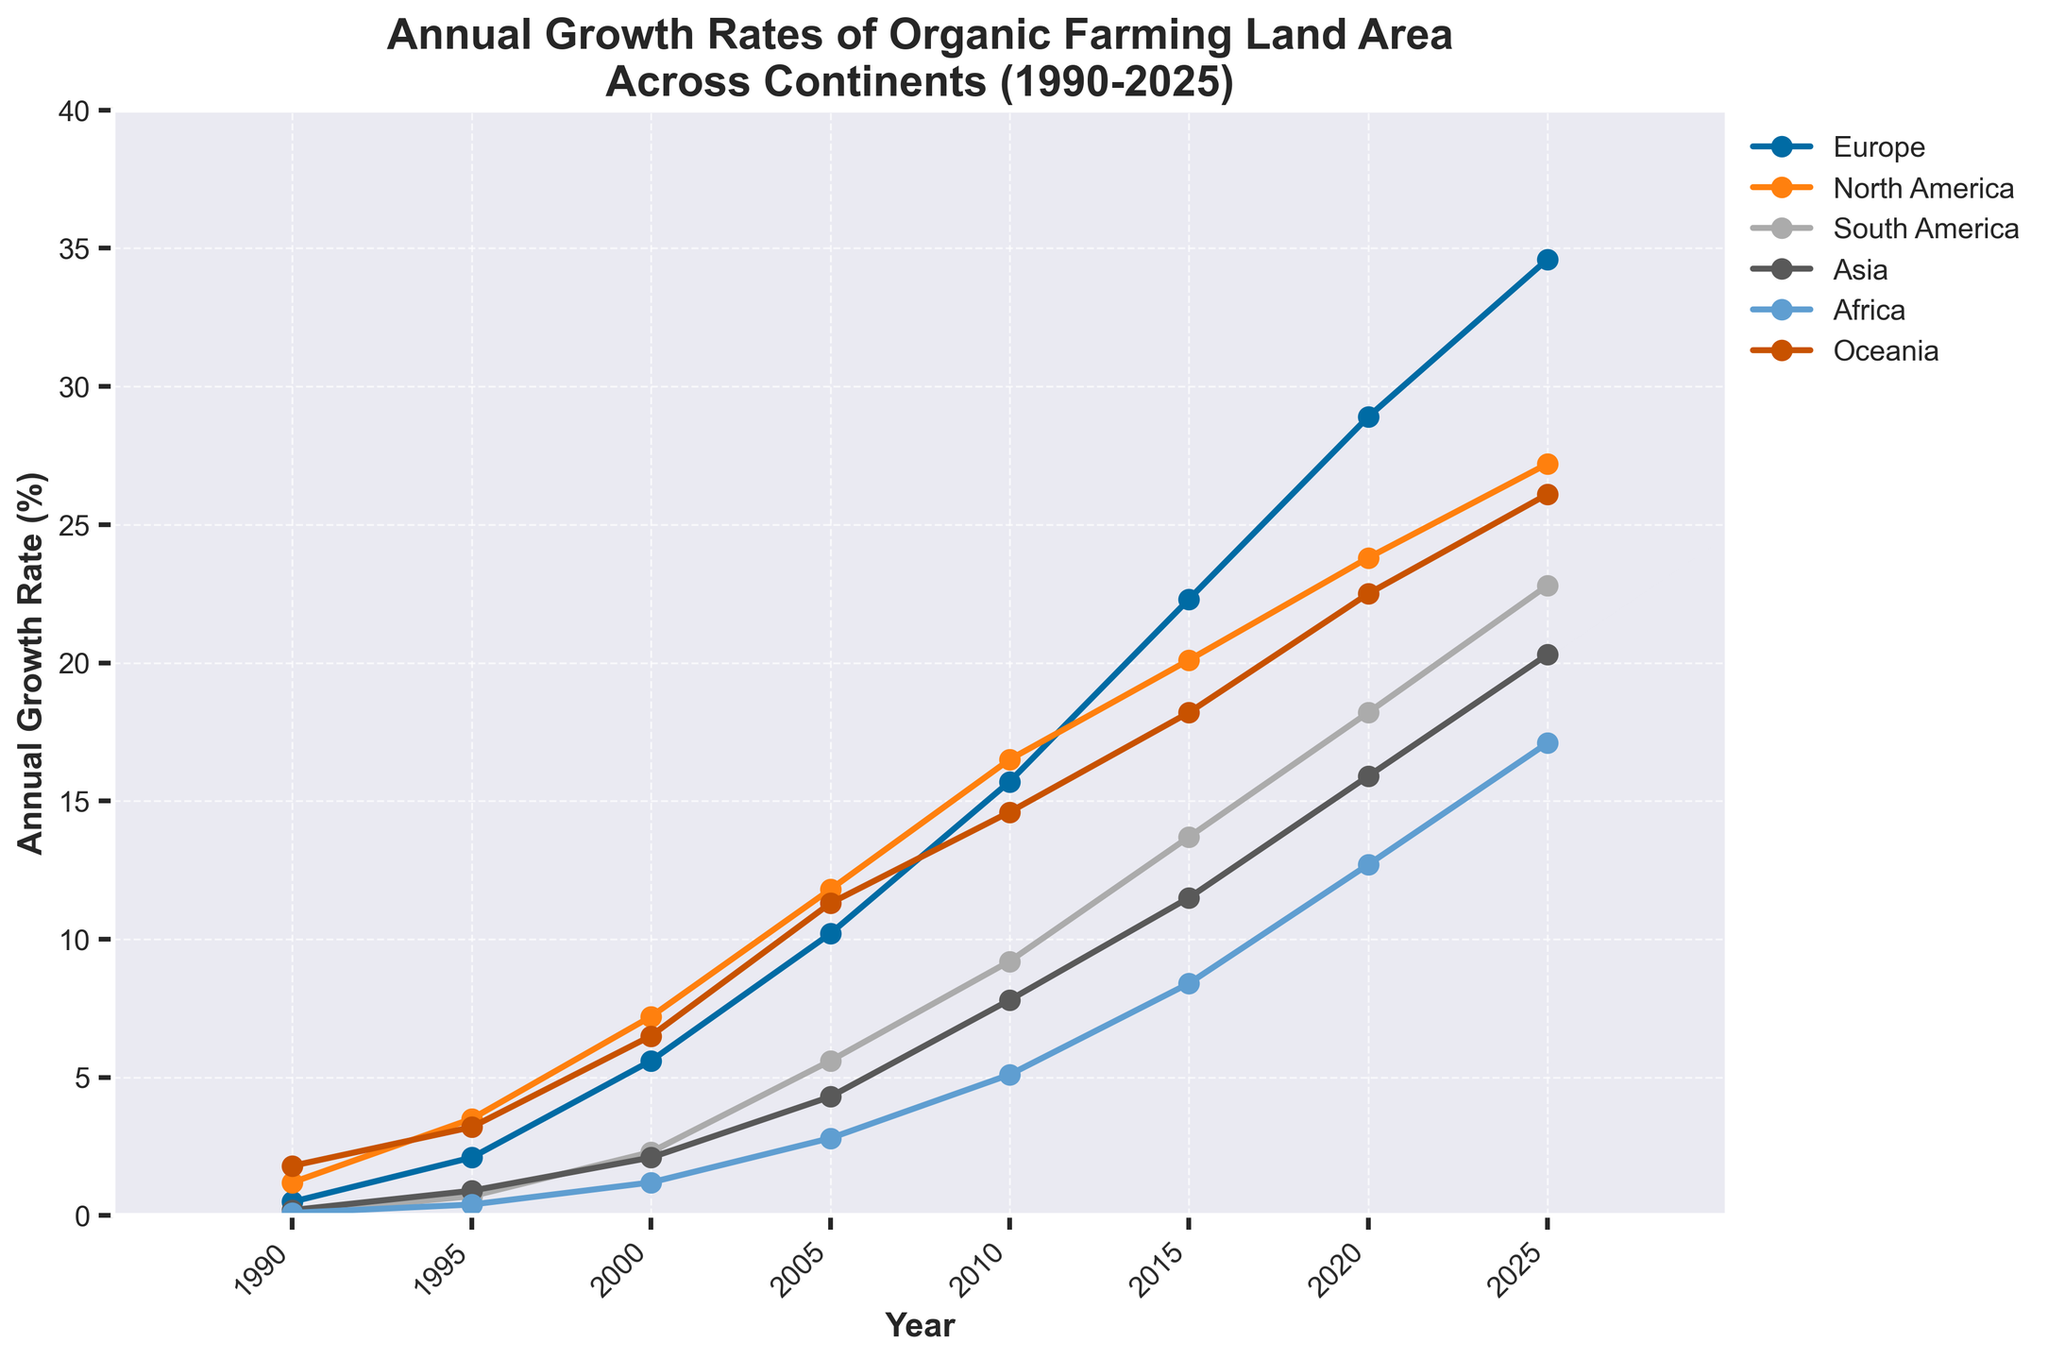What continent had the highest growth rate of organic farming land area in 2020? From the visual representation, in the year 2020, the line representing Europe is the highest on the y-axis compared to other continents, indicating the highest growth rate of organic farming land area.
Answer: Europe Which continent experienced the smallest growth rate increment from 2015 to 2020? By observing the incremental changes, the line for North America has the smallest vertical distance between 2015 and 2020, indicating the smallest growth rate increment among all continents.
Answer: North America What is the average annual growth rate of organic farming land area in Asia from 1995 to 2025? The given data points for Asia from 1995 to 2025 are 0.9, 2.1, 4.3, 7.8, 11.5, 15.9, and 20.3. Calculating the average: (0.9 + 2.1 + 4.3 + 7.8 + 11.5 + 15.9 + 20.3) / 7 = 8.4.
Answer: 8.4 How does the growth rate in Africa in 2025 compare to that in Oceania in the same year? In 2025, the line representing Africa ends around the 17.1 mark, while the line representing Oceania ends around the 26.1 mark. Thus, Oceania's growth rate is higher than Africa's in 2025.
Answer: Oceania's growth is higher What was the difference in the growth rate of organic farming land area between Europe and South America in 2010? In 2010, the growth rate for Europe is approximately 15.7, and for South America, it is approximately 9.2. The difference is 15.7 - 9.2 = 6.5.
Answer: 6.5 Which continent's growth trajectory exhibits the steepest increase from 2000 to 2010? The line with the steepest incline from 2000 to 2010 is for Europe, which indicates it has the steepest increase in growth rate during this period.
Answer: Europe In which year did North America’s growth rate of organic farming surpass 20%? Observing North America's line, it surpasses the 20% mark between 2010 and 2015, specifically in the year 2015.
Answer: 2015 Which two continents had almost parallel growth trends between 2005 and 2010? By visually comparing the slopes between 2005 and 2010, the lines for North America and Oceania are almost parallel, indicating similar growth trends.
Answer: North America and Oceania What was the combined growth rate of organic farming land area for Europe and Asia in 2025? Adding the growth rates for Europe (34.6) and Asia (20.3) in 2025: 34.6 + 20.3 = 54.9.
Answer: 54.9 From 1990 to 2025, which continent showed the most linear growth in organic farming land area? Observing the visual data, Europe shows the most consistent and linear growth trajectory over the years from 1990 to 2025.
Answer: Europe 